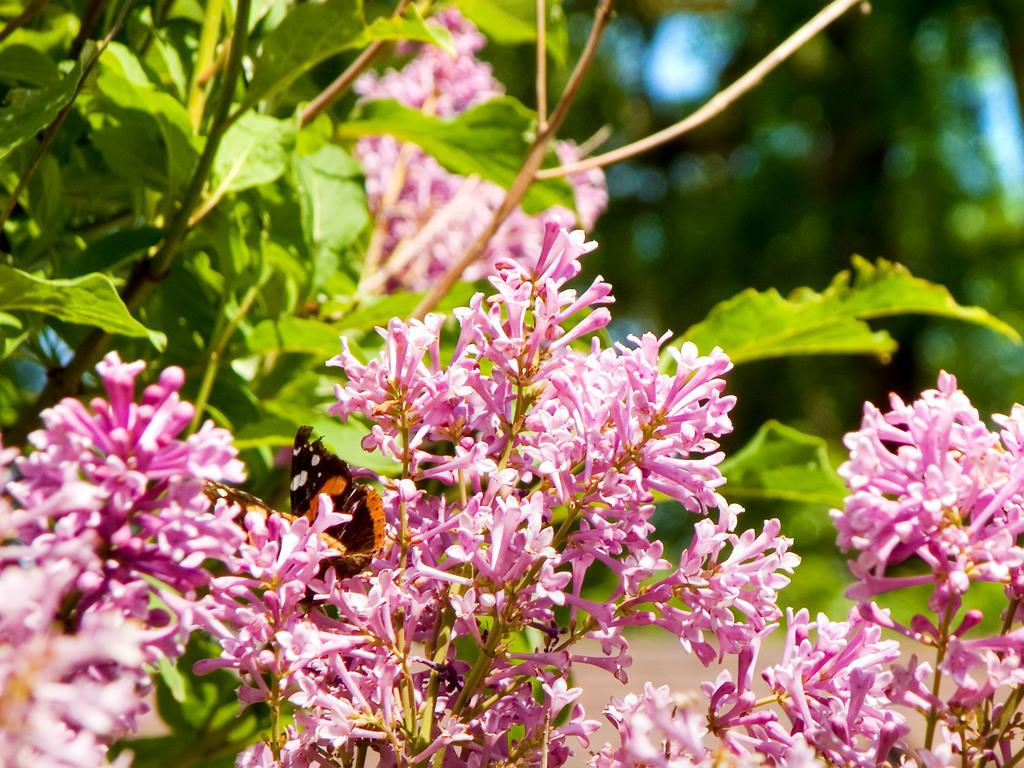What is on the flowers in the image? There is a butterfly on the flowers in the image. Can you describe the flowers in the image? There is a bunch of flowers on the stems of a plant in the image. What type of trains can be seen passing by the flowers in the image? There are no trains present in the image; it features a butterfly on a bunch of flowers. What type of agreement is being made between the butterfly and the flowers in the image? There is no agreement being made between the butterfly and the flowers in the image; it is a natural interaction between a butterfly and flowers. 